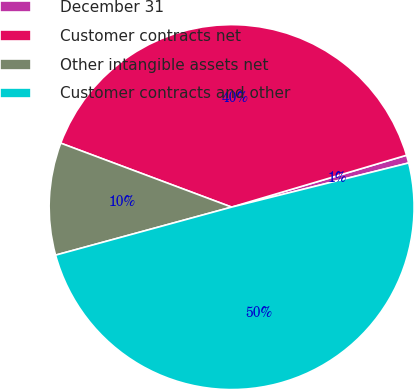Convert chart. <chart><loc_0><loc_0><loc_500><loc_500><pie_chart><fcel>December 31<fcel>Customer contracts net<fcel>Other intangible assets net<fcel>Customer contracts and other<nl><fcel>0.7%<fcel>39.71%<fcel>9.94%<fcel>49.65%<nl></chart> 